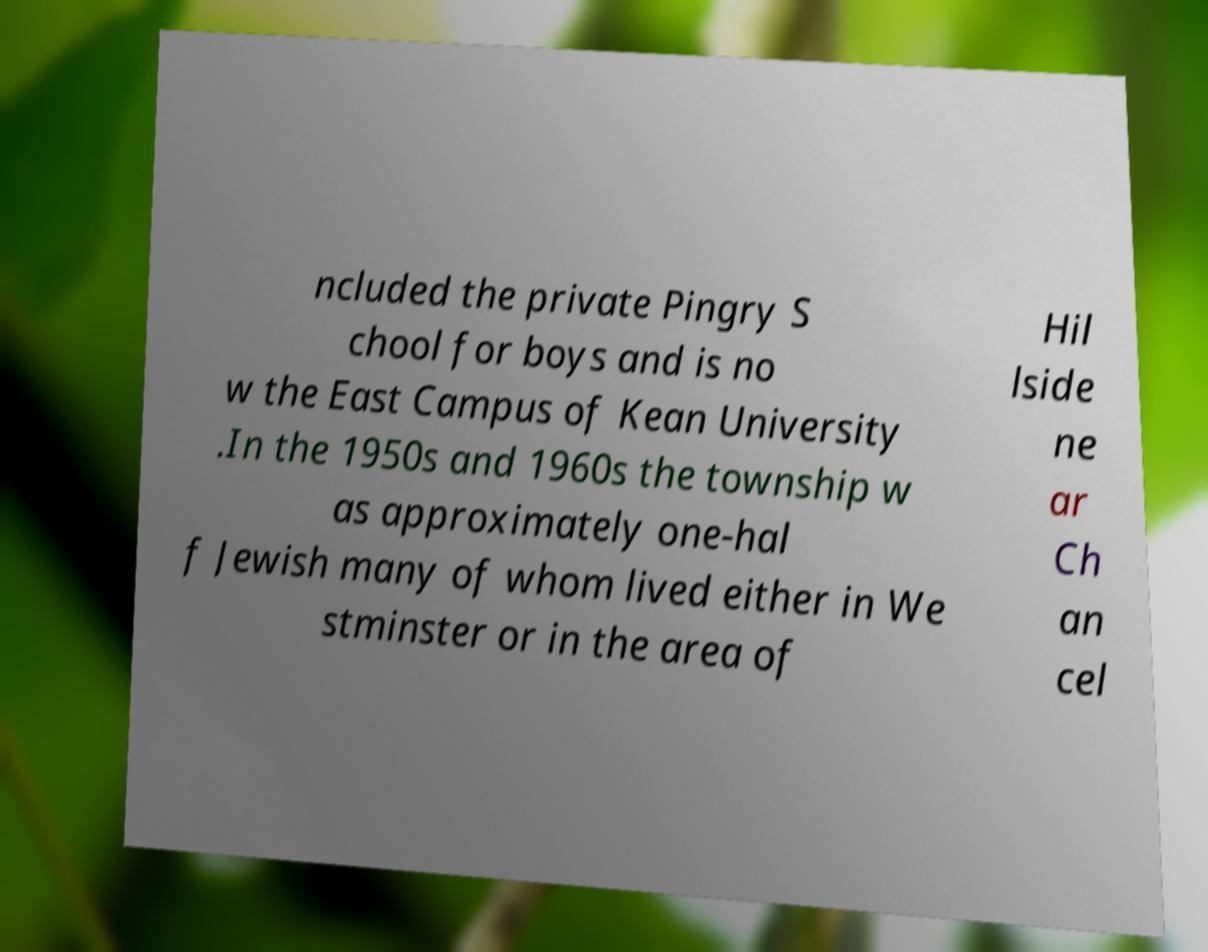Please read and relay the text visible in this image. What does it say? ncluded the private Pingry S chool for boys and is no w the East Campus of Kean University .In the 1950s and 1960s the township w as approximately one-hal f Jewish many of whom lived either in We stminster or in the area of Hil lside ne ar Ch an cel 